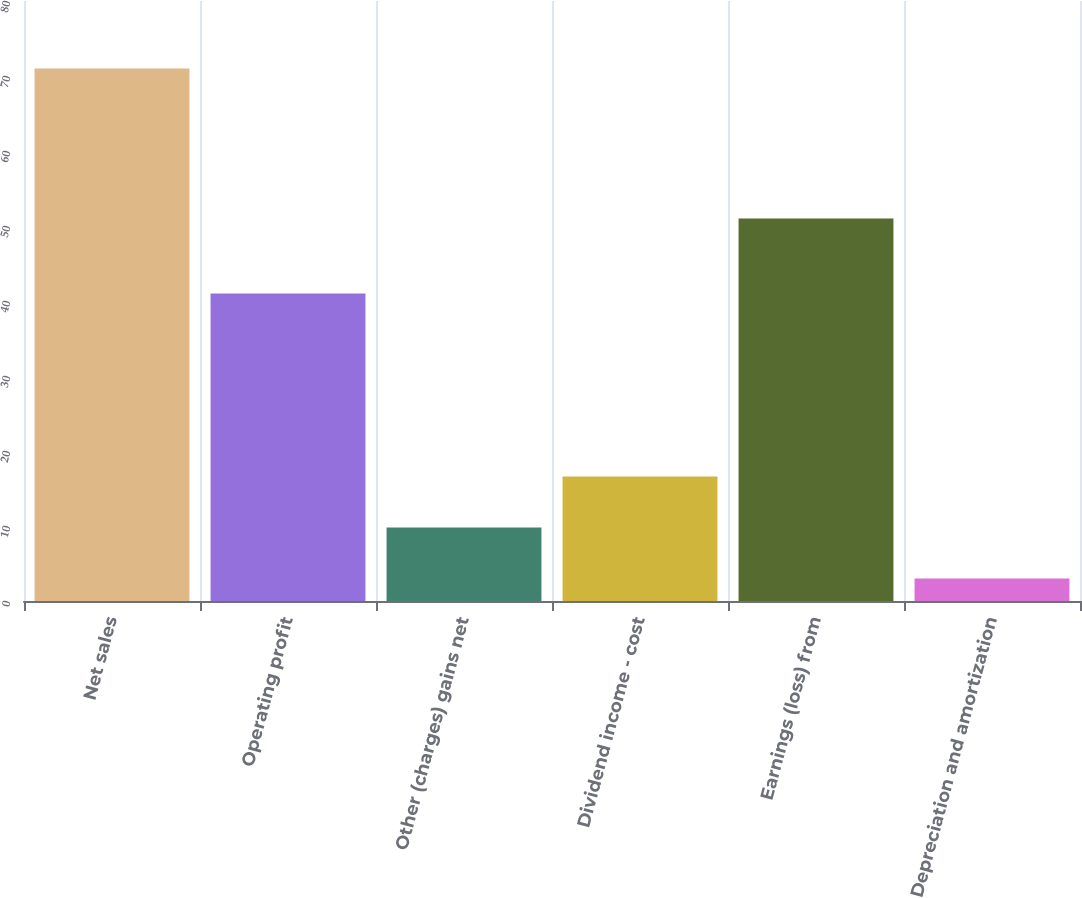<chart> <loc_0><loc_0><loc_500><loc_500><bar_chart><fcel>Net sales<fcel>Operating profit<fcel>Other (charges) gains net<fcel>Dividend income - cost<fcel>Earnings (loss) from<fcel>Depreciation and amortization<nl><fcel>71<fcel>41<fcel>9.8<fcel>16.6<fcel>51<fcel>3<nl></chart> 